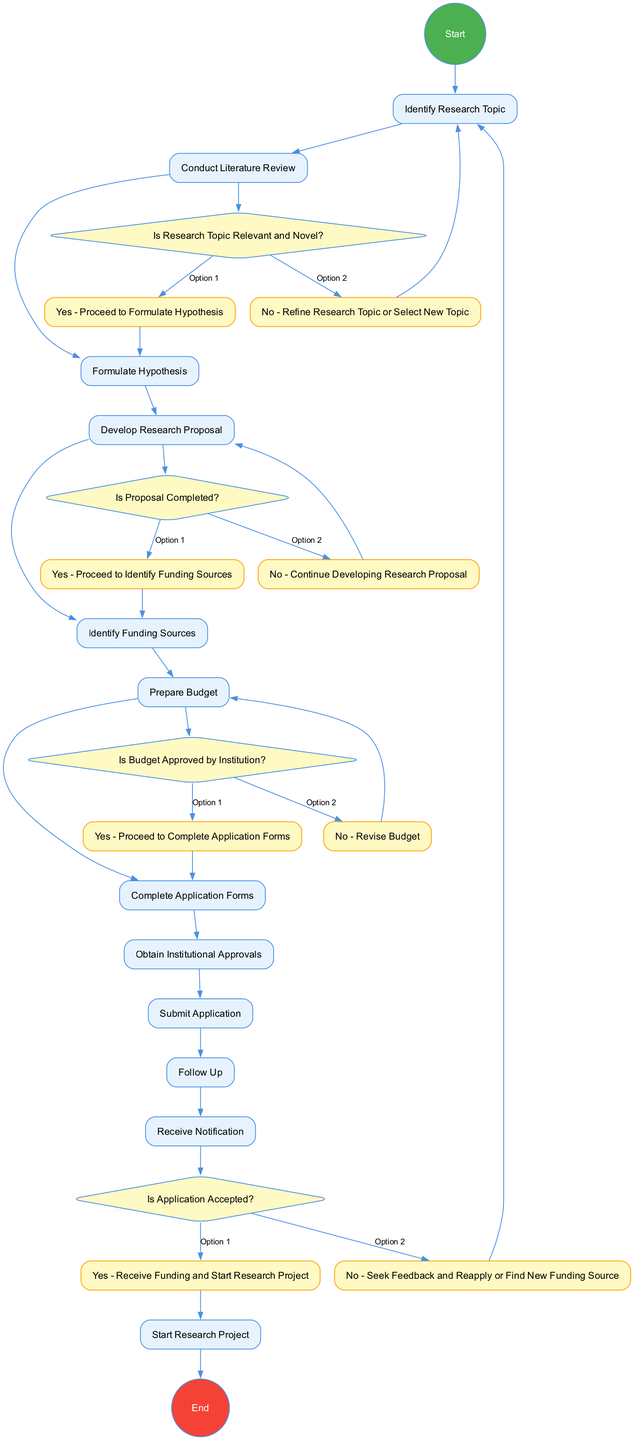What's the first action in the diagram? The first action in the diagram is labeled "Identify Research Topic," which is directly connected from the "Start" node, indicating it comes immediately after the initiation of the process.
Answer: Identify Research Topic How many decision nodes are there in the diagram? The diagram features four decision nodes, each marked with a diamond shape. These decisions present various options that lead to different subsequent actions based on the responses.
Answer: 4 What do you do if the research topic is not relevant and novel? If the research topic is not relevant and novel, per the decision node's options, the next step is to "Refine Research Topic or Select New Topic," which connects back to the action "Identify Research Topic."
Answer: Refine Research Topic or Select New Topic What is required before proceeding to identify funding sources? Before proceeding to identify funding sources, the proposal must be completed. This is dictated by the decision node that connects to the action "Identify Funding Sources" only if the proposal is confirmed as complete.
Answer: Proposal Completed What happens if the budget is not approved by the institution? If the budget is not approved by the institution, the diagram indicates that you need to "Revise Budget." This is part of the flow where the decision node guides you back to making necessary adjustments before proceeding to the application forms.
Answer: Revise Budget What is the final action in the diagram? The final action in the diagram is "Start Research Project," which occurs if the application is accepted. This action marks the conclusion of the process detailed in the diagram.
Answer: Start Research Project 